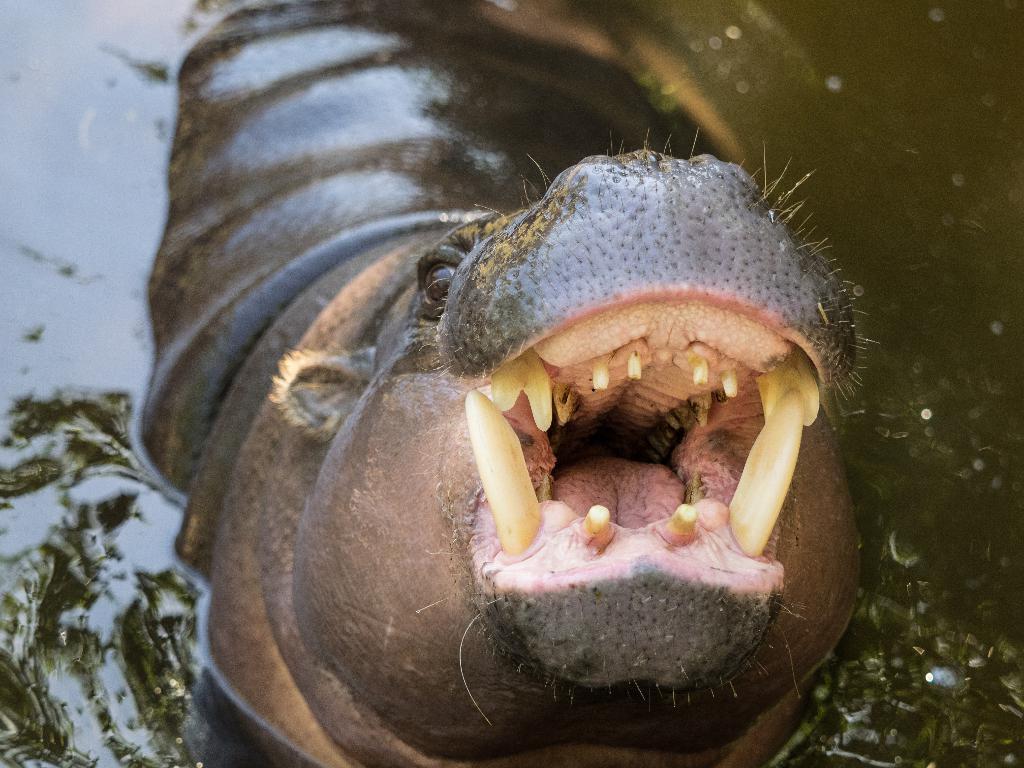How would you summarize this image in a sentence or two? In this image we can see an animal in the water. 